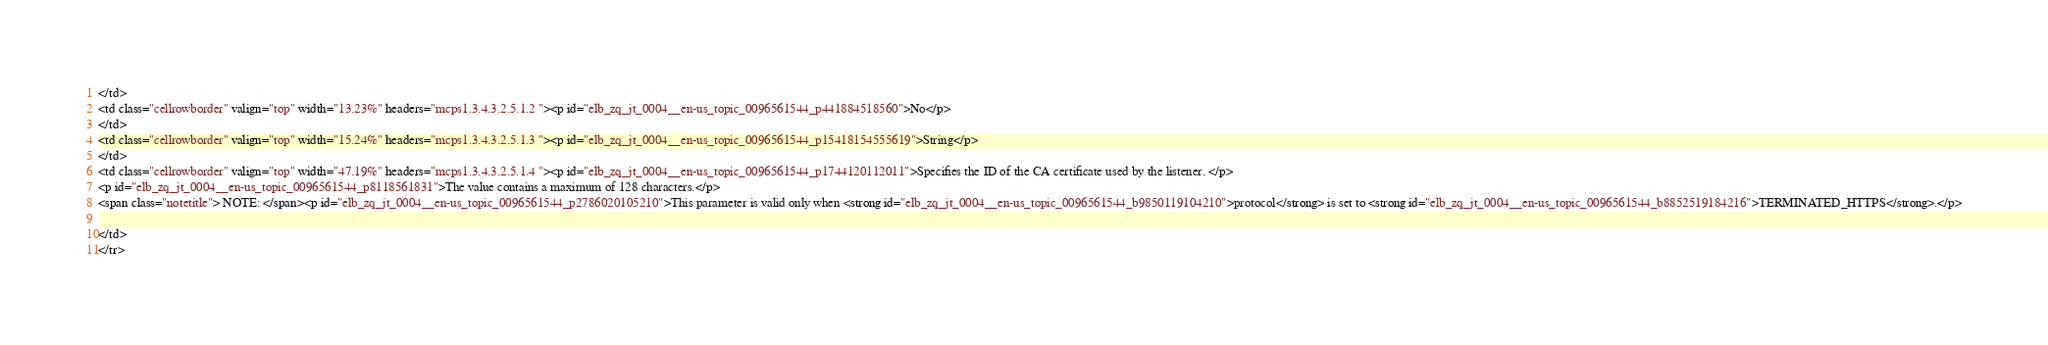<code> <loc_0><loc_0><loc_500><loc_500><_HTML_></td>
<td class="cellrowborder" valign="top" width="13.23%" headers="mcps1.3.4.3.2.5.1.2 "><p id="elb_zq_jt_0004__en-us_topic_0096561544_p441884518560">No</p>
</td>
<td class="cellrowborder" valign="top" width="15.24%" headers="mcps1.3.4.3.2.5.1.3 "><p id="elb_zq_jt_0004__en-us_topic_0096561544_p15418154555619">String</p>
</td>
<td class="cellrowborder" valign="top" width="47.19%" headers="mcps1.3.4.3.2.5.1.4 "><p id="elb_zq_jt_0004__en-us_topic_0096561544_p1744120112011">Specifies the ID of the CA certificate used by the listener. </p>
<p id="elb_zq_jt_0004__en-us_topic_0096561544_p8118561831">The value contains a maximum of 128 characters.</p>
<span class="notetitle"> NOTE: </span><p id="elb_zq_jt_0004__en-us_topic_0096561544_p2786020105210">This parameter is valid only when <strong id="elb_zq_jt_0004__en-us_topic_0096561544_b9850119104210">protocol</strong> is set to <strong id="elb_zq_jt_0004__en-us_topic_0096561544_b8852519184216">TERMINATED_HTTPS</strong>.</p>

</td>
</tr></code> 